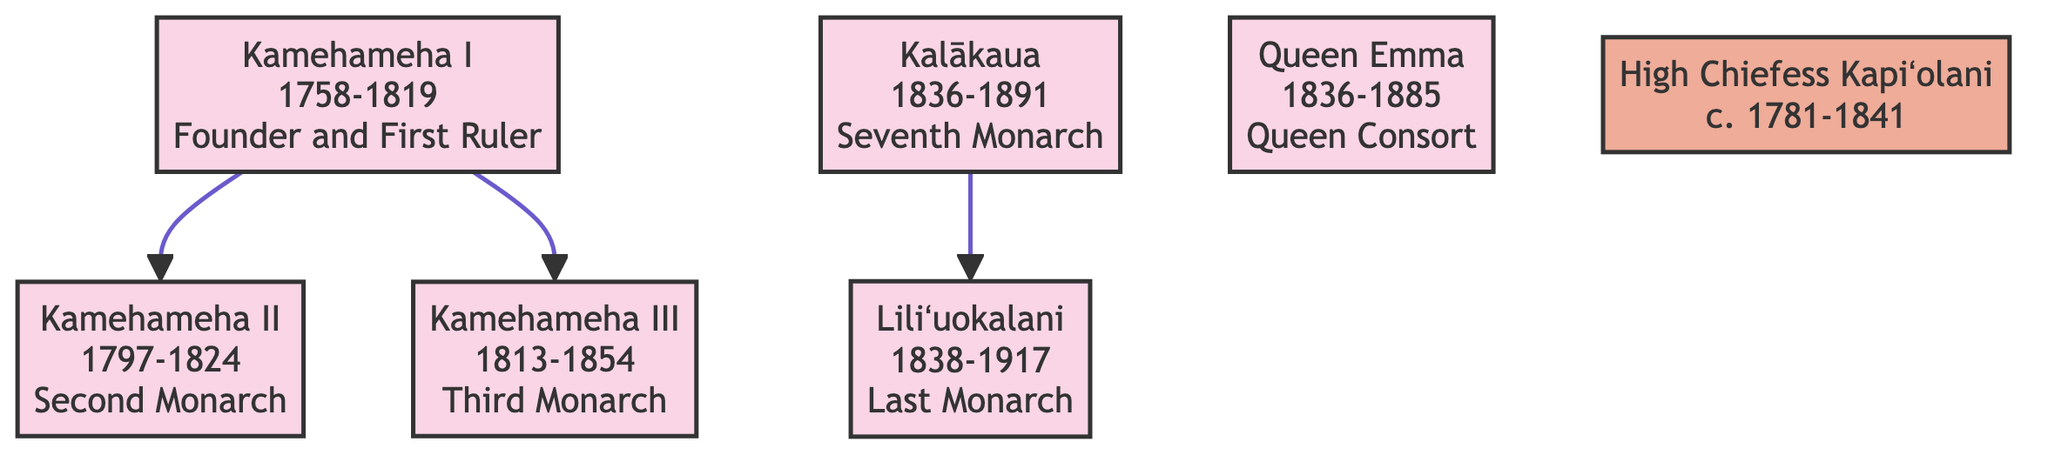What is the lifespan of Kamehameha I? The diagram specifies the lifespan of Kamehameha I as 1758-1819, which is directly noted in his node.
Answer: 1758-1819 Who is the last monarch of Hawaii? The diagram clearly indicates Liliʻuokalani as the last monarch of Hawaii in her node.
Answer: Liliʻuokalani How many descendants does Kamehameha I have listed? By examining the diagram, we see two descendants, Kamehameha II and Kamehameha III, branching from Kamehameha I.
Answer: 2 What role did Queen Emma hold? The node for Queen Emma explicitly states her role as Queen Consort of King Kamehameha IV, which is a clear representation in the diagram.
Answer: Queen Consort Which monarch was involved in the protection of marine territories through legal frameworks? The node for Kamehameha III includes his contribution related to marine territories, specifically mentioning legal frameworks for their protection.
Answer: Kamehameha III Who promoted Hawaiian culture and traditions? The diagram notes that Kalākaua, as the seventh monarch, was the one who promoted Hawaiian culture and traditions, as stated in his contributions.
Answer: Kalākaua What significant marine habitat did High Chiefess Kapiʻolani advocate for? The diagram indicates that High Chiefess Kapiʻolani advocated for the protection of Kealakekua Bay, specifically mentioned in her contributions.
Answer: Kealakekua Bay What is one of the contributions of Kamehameha II? The contributions of Kamehameha II, as listed in the diagram, include continuing unification policies, which is specifically highlighted.
Answer: Continued unification policies Which monarch authored works promoting marine conservation? The diagram shows that Liliʻuokalani, the last monarch, authored multiple works promoting marine conservation, explicitly stated in her contributions.
Answer: Liliʻuokalani 